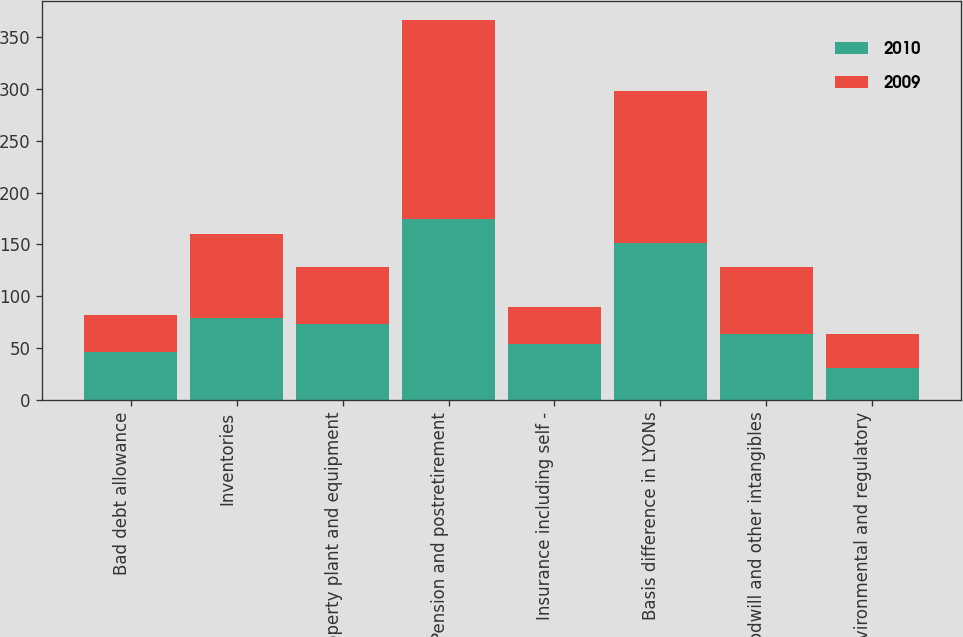Convert chart to OTSL. <chart><loc_0><loc_0><loc_500><loc_500><stacked_bar_chart><ecel><fcel>Bad debt allowance<fcel>Inventories<fcel>Property plant and equipment<fcel>Pension and postretirement<fcel>Insurance including self -<fcel>Basis difference in LYONs<fcel>Goodwill and other intangibles<fcel>Environmental and regulatory<nl><fcel>2010<fcel>46.3<fcel>78.8<fcel>73.3<fcel>174.1<fcel>54.4<fcel>151.3<fcel>64.05<fcel>30.8<nl><fcel>2009<fcel>35.6<fcel>81.4<fcel>54.8<fcel>192.3<fcel>35.5<fcel>146.6<fcel>64.05<fcel>33.2<nl></chart> 